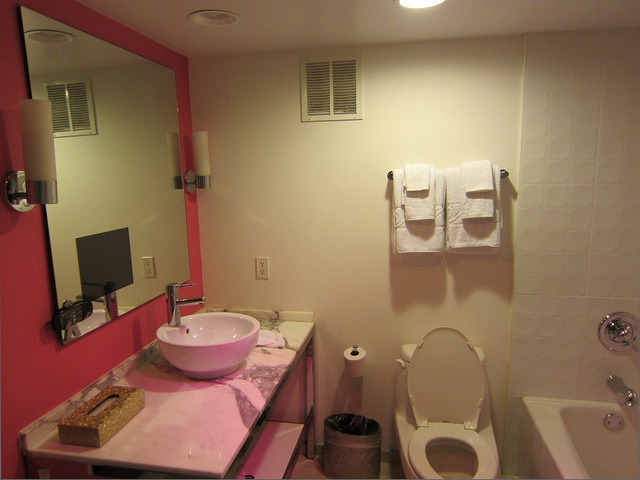Describe the objects in this image and their specific colors. I can see toilet in maroon, gray, tan, and brown tones, sink in maroon, brown, and tan tones, and sink in maroon, tan, gray, brown, and darkgray tones in this image. 